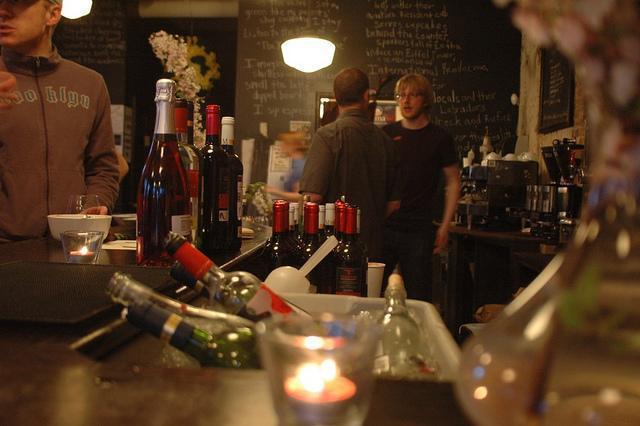Where are these people located?
From the following set of four choices, select the accurate answer to respond to the question.
Options: Restaurant, classroom, office, theater. Restaurant. 